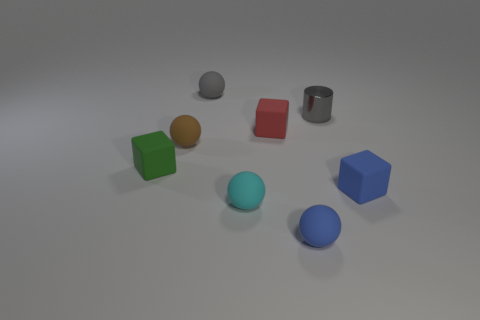Add 1 big rubber things. How many objects exist? 9 Subtract all blocks. How many objects are left? 5 Subtract 0 yellow balls. How many objects are left? 8 Subtract all tiny green objects. Subtract all small blue matte balls. How many objects are left? 6 Add 5 gray things. How many gray things are left? 7 Add 6 tiny gray cylinders. How many tiny gray cylinders exist? 7 